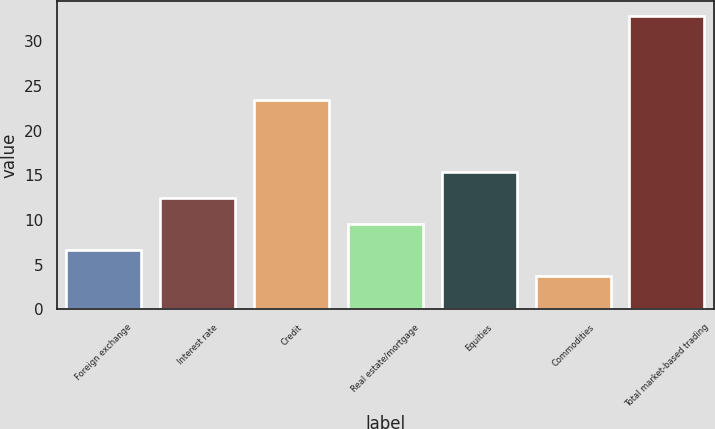Convert chart to OTSL. <chart><loc_0><loc_0><loc_500><loc_500><bar_chart><fcel>Foreign exchange<fcel>Interest rate<fcel>Credit<fcel>Real estate/mortgage<fcel>Equities<fcel>Commodities<fcel>Total market-based trading<nl><fcel>6.62<fcel>12.46<fcel>23.4<fcel>9.54<fcel>15.38<fcel>3.7<fcel>32.9<nl></chart> 